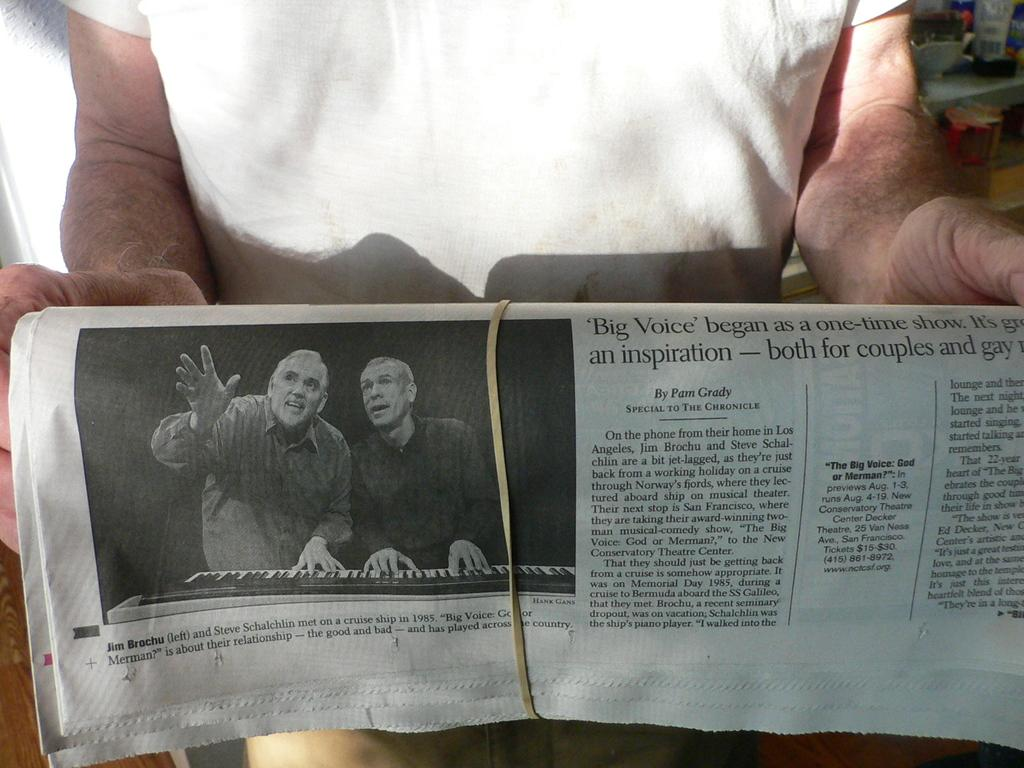<image>
Render a clear and concise summary of the photo. Man holding a vintage newspaper of Jim Brochu and Steve playing a piano. 